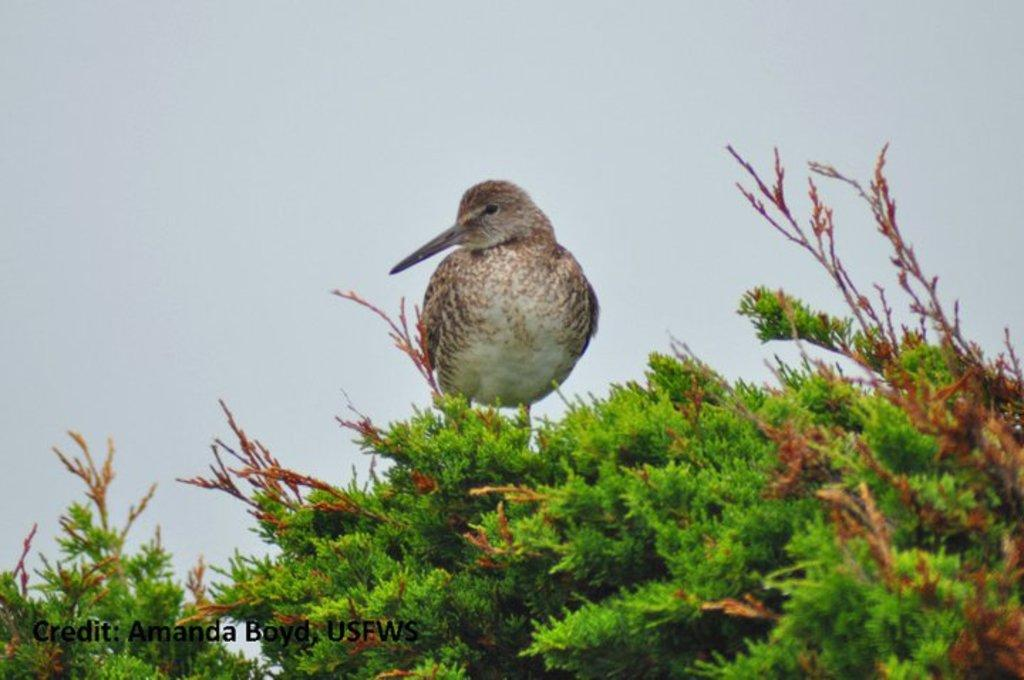What type of animal can be seen in the image? There is a bird in the image. Where is the bird located in the image? The bird is sitting at the top of a tree. Is there any text present in the image? Yes, there is some text at the bottom of the image. How does the bird pull the veil in the image? There is no veil present in the image, so the bird cannot pull it. 